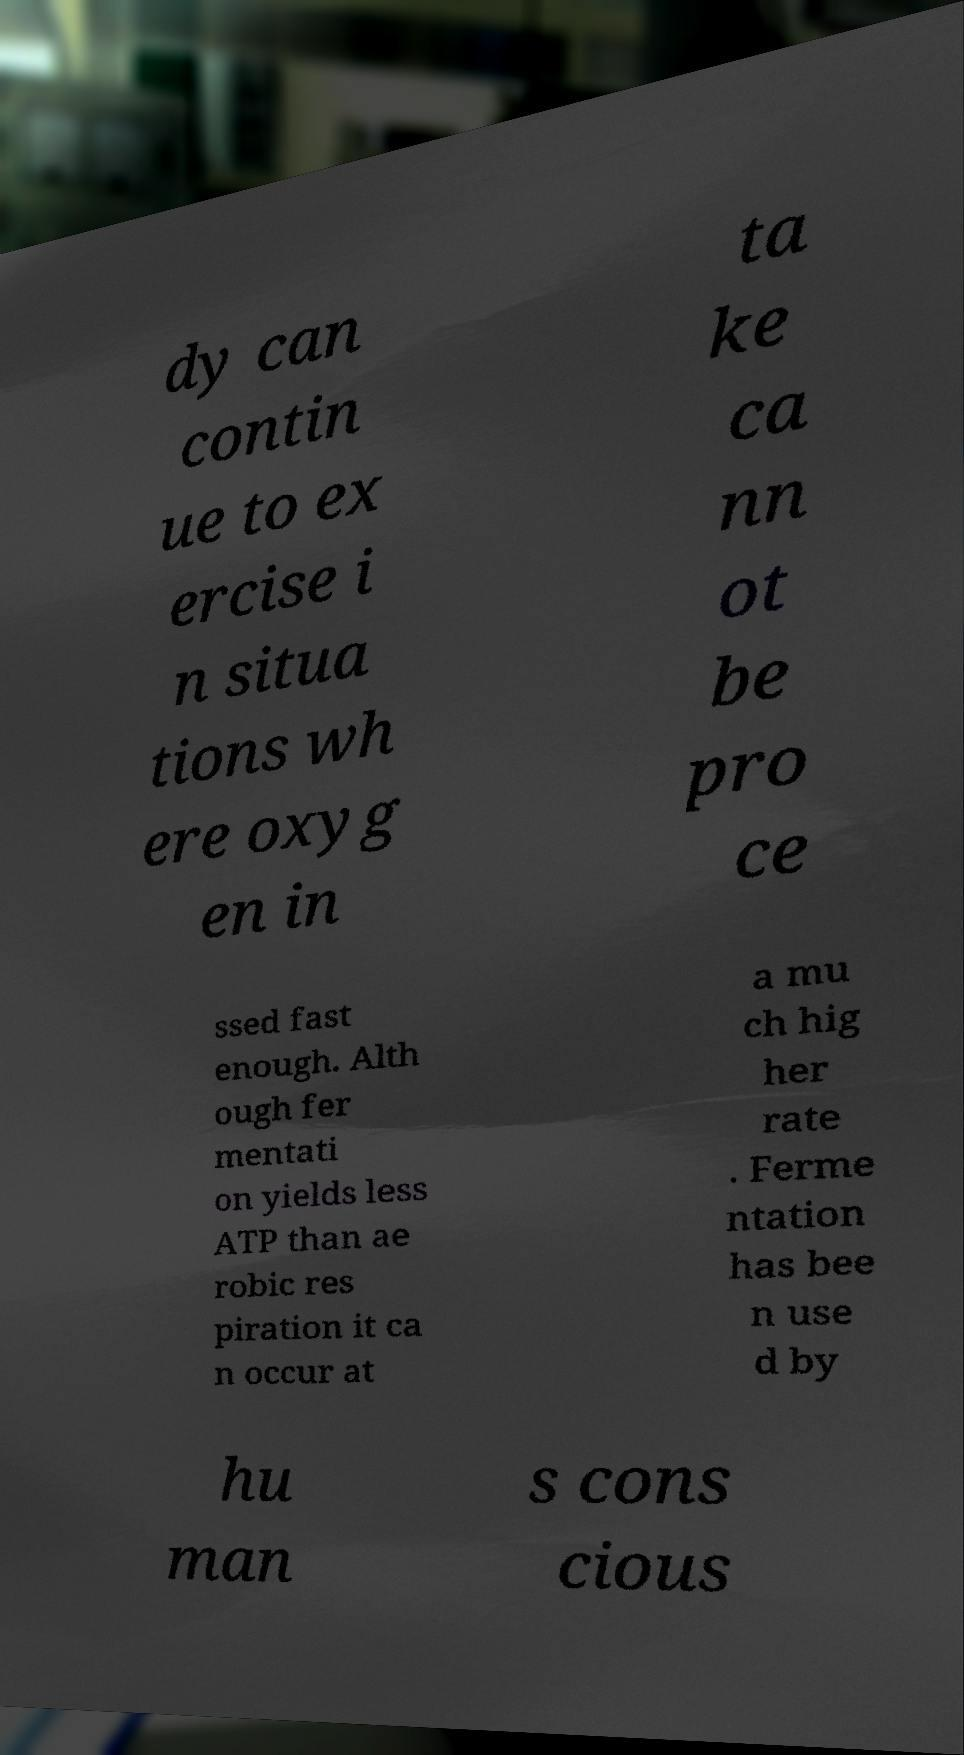Please identify and transcribe the text found in this image. dy can contin ue to ex ercise i n situa tions wh ere oxyg en in ta ke ca nn ot be pro ce ssed fast enough. Alth ough fer mentati on yields less ATP than ae robic res piration it ca n occur at a mu ch hig her rate . Ferme ntation has bee n use d by hu man s cons cious 